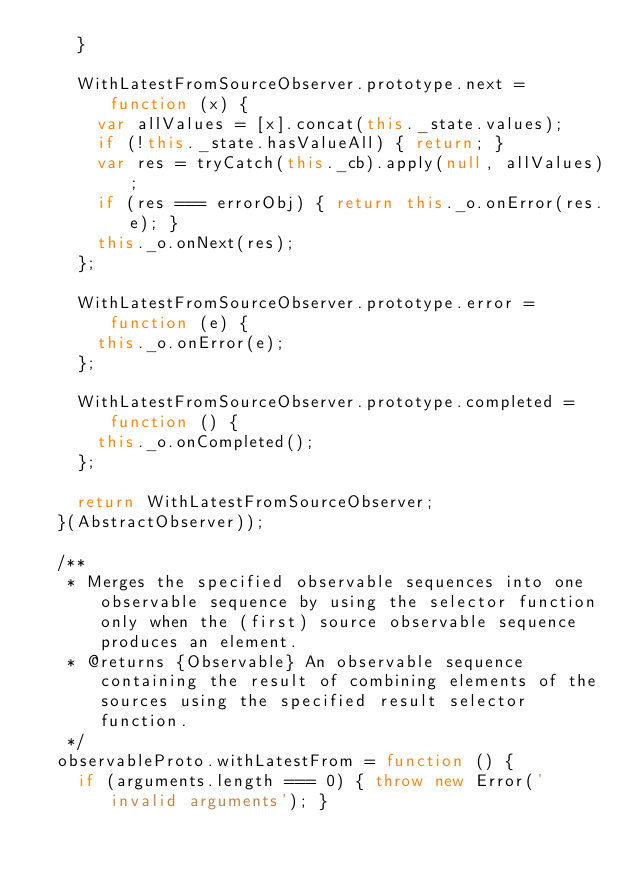Convert code to text. <code><loc_0><loc_0><loc_500><loc_500><_JavaScript_>    }

    WithLatestFromSourceObserver.prototype.next = function (x) {
      var allValues = [x].concat(this._state.values);
      if (!this._state.hasValueAll) { return; }
      var res = tryCatch(this._cb).apply(null, allValues);
      if (res === errorObj) { return this._o.onError(res.e); }
      this._o.onNext(res);
    };

    WithLatestFromSourceObserver.prototype.error = function (e) {
      this._o.onError(e);
    };

    WithLatestFromSourceObserver.prototype.completed = function () {
      this._o.onCompleted();
    };

    return WithLatestFromSourceObserver;
  }(AbstractObserver));

  /**
   * Merges the specified observable sequences into one observable sequence by using the selector function only when the (first) source observable sequence produces an element.
   * @returns {Observable} An observable sequence containing the result of combining elements of the sources using the specified result selector function.
   */
  observableProto.withLatestFrom = function () {
    if (arguments.length === 0) { throw new Error('invalid arguments'); }
</code> 